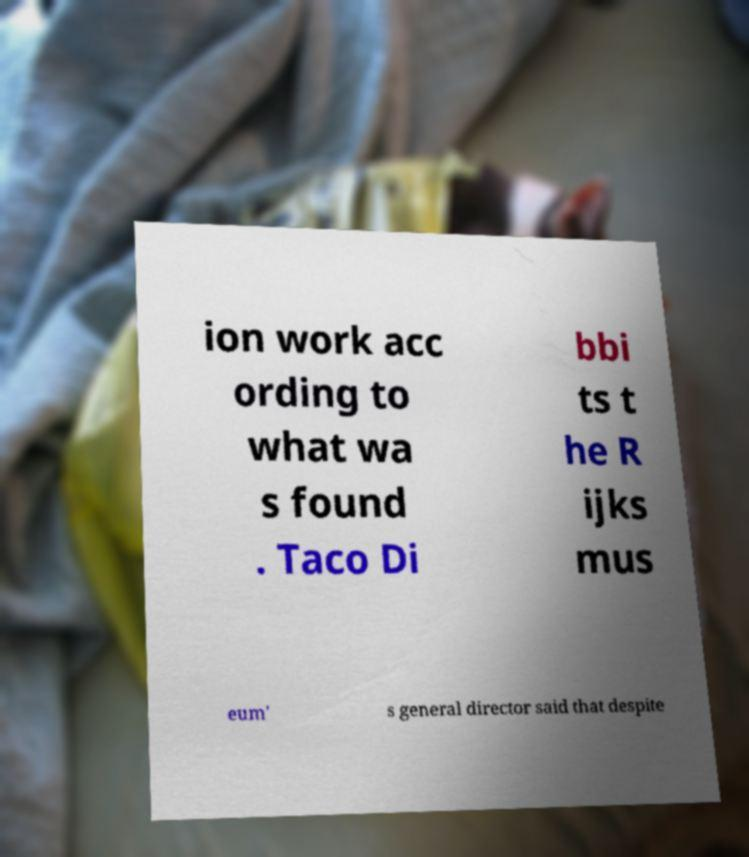What messages or text are displayed in this image? I need them in a readable, typed format. ion work acc ording to what wa s found . Taco Di bbi ts t he R ijks mus eum' s general director said that despite 